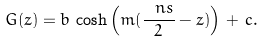Convert formula to latex. <formula><loc_0><loc_0><loc_500><loc_500>G ( z ) = b \, \cosh \left ( m ( \frac { \ n s } { 2 } - z ) \right ) \, + \, c .</formula> 